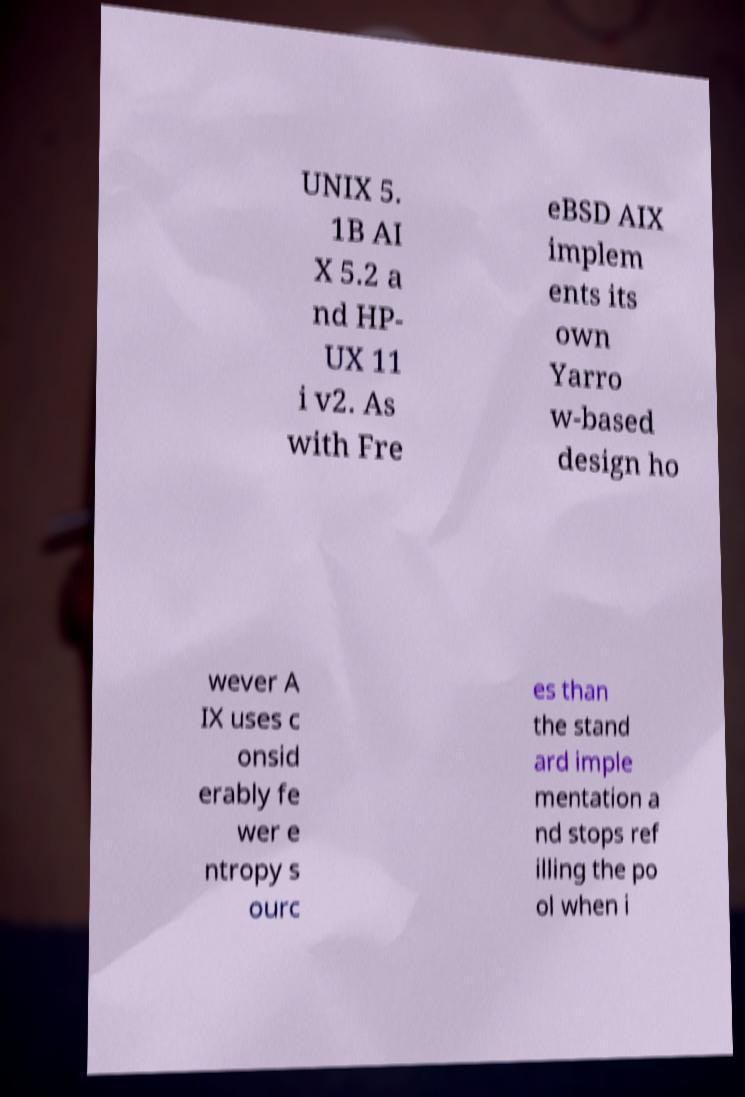For documentation purposes, I need the text within this image transcribed. Could you provide that? UNIX 5. 1B AI X 5.2 a nd HP- UX 11 i v2. As with Fre eBSD AIX implem ents its own Yarro w-based design ho wever A IX uses c onsid erably fe wer e ntropy s ourc es than the stand ard imple mentation a nd stops ref illing the po ol when i 